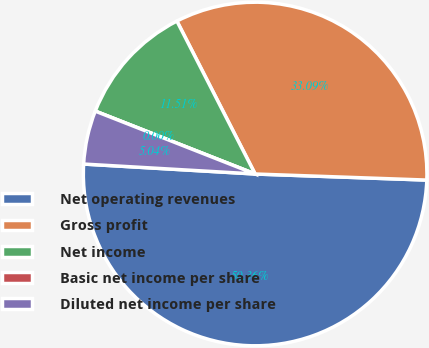<chart> <loc_0><loc_0><loc_500><loc_500><pie_chart><fcel>Net operating revenues<fcel>Gross profit<fcel>Net income<fcel>Basic net income per share<fcel>Diluted net income per share<nl><fcel>50.36%<fcel>33.09%<fcel>11.51%<fcel>0.0%<fcel>5.04%<nl></chart> 